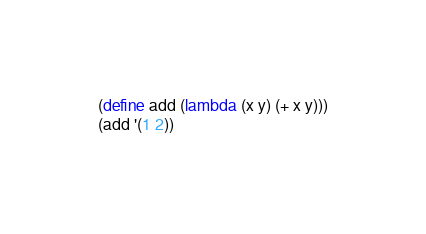<code> <loc_0><loc_0><loc_500><loc_500><_Scheme_>(define add (lambda (x y) (+ x y)))
(add '(1 2))
</code> 